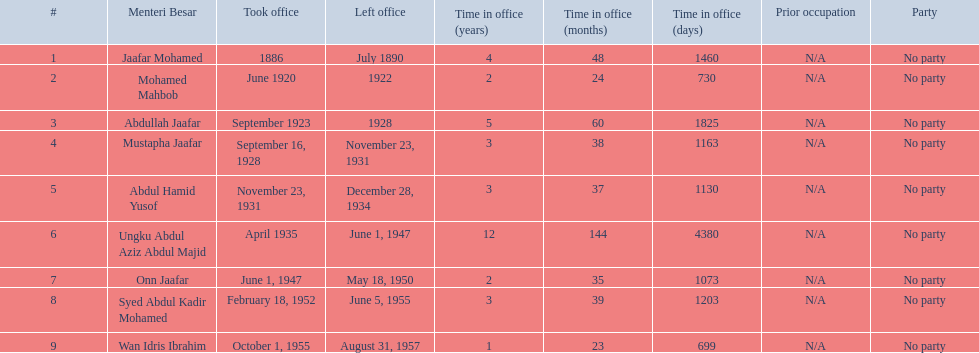Which menteri besars took office in the 1920's? Mohamed Mahbob, Abdullah Jaafar, Mustapha Jaafar. Of those men, who was only in office for 2 years? Mohamed Mahbob. 